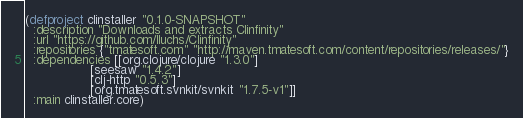Convert code to text. <code><loc_0><loc_0><loc_500><loc_500><_Clojure_>(defproject clinstaller "0.1.0-SNAPSHOT"
  :description "Downloads and extracts Clinfinity"
  :url "https://github.com/lluchs/Clinfinity"
  :repositories {"tmatesoft.com" "http://maven.tmatesoft.com/content/repositories/releases/"}
  :dependencies [[org.clojure/clojure "1.3.0"]
                 [seesaw "1.4.2"]
                 [clj-http "0.5.3"]
                 [org.tmatesoft.svnkit/svnkit "1.7.5-v1"]]
  :main clinstaller.core)
</code> 